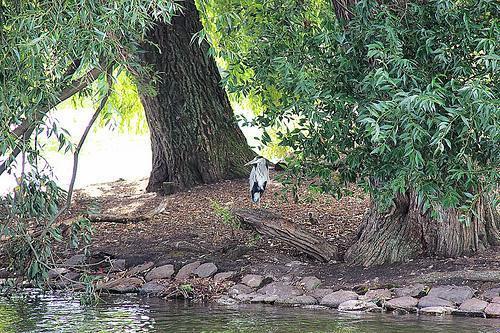How many birds are shown?
Give a very brief answer. 1. 